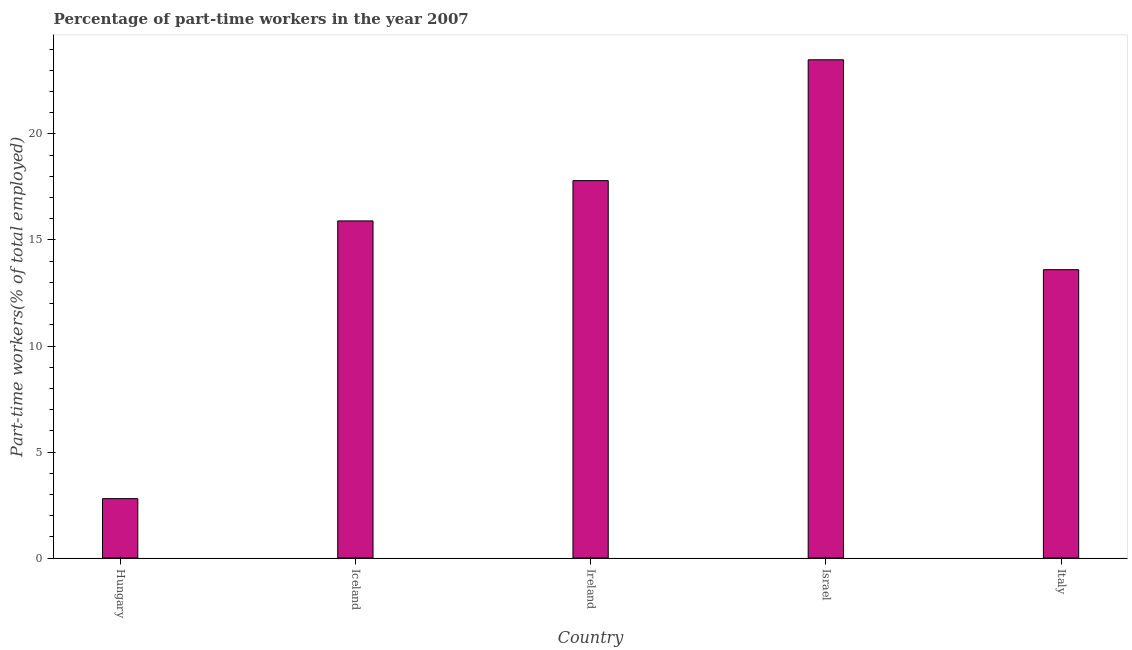Does the graph contain any zero values?
Your answer should be very brief. No. Does the graph contain grids?
Your response must be concise. No. What is the title of the graph?
Give a very brief answer. Percentage of part-time workers in the year 2007. What is the label or title of the Y-axis?
Keep it short and to the point. Part-time workers(% of total employed). What is the percentage of part-time workers in Iceland?
Your response must be concise. 15.9. Across all countries, what is the maximum percentage of part-time workers?
Keep it short and to the point. 23.5. Across all countries, what is the minimum percentage of part-time workers?
Your answer should be compact. 2.8. In which country was the percentage of part-time workers maximum?
Provide a succinct answer. Israel. In which country was the percentage of part-time workers minimum?
Make the answer very short. Hungary. What is the sum of the percentage of part-time workers?
Make the answer very short. 73.6. What is the average percentage of part-time workers per country?
Your answer should be compact. 14.72. What is the median percentage of part-time workers?
Make the answer very short. 15.9. What is the ratio of the percentage of part-time workers in Hungary to that in Iceland?
Offer a terse response. 0.18. What is the difference between the highest and the second highest percentage of part-time workers?
Your response must be concise. 5.7. Is the sum of the percentage of part-time workers in Iceland and Ireland greater than the maximum percentage of part-time workers across all countries?
Ensure brevity in your answer.  Yes. What is the difference between the highest and the lowest percentage of part-time workers?
Provide a short and direct response. 20.7. Are all the bars in the graph horizontal?
Provide a succinct answer. No. What is the Part-time workers(% of total employed) in Hungary?
Your response must be concise. 2.8. What is the Part-time workers(% of total employed) of Iceland?
Provide a short and direct response. 15.9. What is the Part-time workers(% of total employed) of Ireland?
Provide a short and direct response. 17.8. What is the Part-time workers(% of total employed) in Israel?
Keep it short and to the point. 23.5. What is the Part-time workers(% of total employed) of Italy?
Your response must be concise. 13.6. What is the difference between the Part-time workers(% of total employed) in Hungary and Iceland?
Provide a succinct answer. -13.1. What is the difference between the Part-time workers(% of total employed) in Hungary and Israel?
Provide a succinct answer. -20.7. What is the difference between the Part-time workers(% of total employed) in Iceland and Ireland?
Ensure brevity in your answer.  -1.9. What is the difference between the Part-time workers(% of total employed) in Ireland and Israel?
Your answer should be very brief. -5.7. What is the difference between the Part-time workers(% of total employed) in Ireland and Italy?
Your answer should be compact. 4.2. What is the difference between the Part-time workers(% of total employed) in Israel and Italy?
Give a very brief answer. 9.9. What is the ratio of the Part-time workers(% of total employed) in Hungary to that in Iceland?
Ensure brevity in your answer.  0.18. What is the ratio of the Part-time workers(% of total employed) in Hungary to that in Ireland?
Give a very brief answer. 0.16. What is the ratio of the Part-time workers(% of total employed) in Hungary to that in Israel?
Provide a succinct answer. 0.12. What is the ratio of the Part-time workers(% of total employed) in Hungary to that in Italy?
Give a very brief answer. 0.21. What is the ratio of the Part-time workers(% of total employed) in Iceland to that in Ireland?
Your response must be concise. 0.89. What is the ratio of the Part-time workers(% of total employed) in Iceland to that in Israel?
Offer a very short reply. 0.68. What is the ratio of the Part-time workers(% of total employed) in Iceland to that in Italy?
Your answer should be very brief. 1.17. What is the ratio of the Part-time workers(% of total employed) in Ireland to that in Israel?
Ensure brevity in your answer.  0.76. What is the ratio of the Part-time workers(% of total employed) in Ireland to that in Italy?
Provide a succinct answer. 1.31. What is the ratio of the Part-time workers(% of total employed) in Israel to that in Italy?
Your response must be concise. 1.73. 